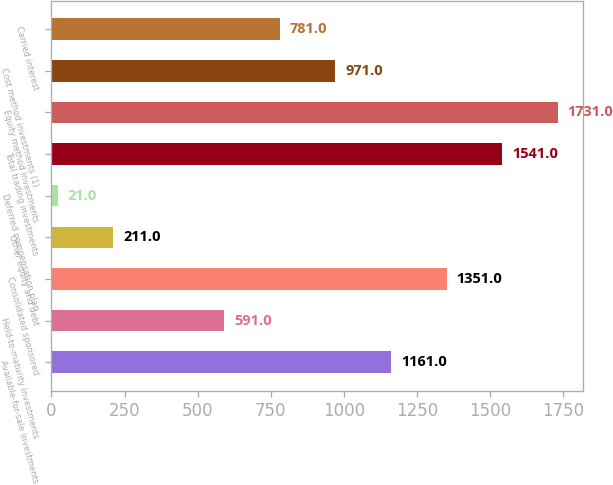<chart> <loc_0><loc_0><loc_500><loc_500><bar_chart><fcel>Available-for-sale investments<fcel>Held-to-maturity investments<fcel>Consolidated sponsored<fcel>Other equity and debt<fcel>Deferred compensation plan<fcel>Total trading investments<fcel>Equity method investments<fcel>Cost method investments (1)<fcel>Carried interest<nl><fcel>1161<fcel>591<fcel>1351<fcel>211<fcel>21<fcel>1541<fcel>1731<fcel>971<fcel>781<nl></chart> 